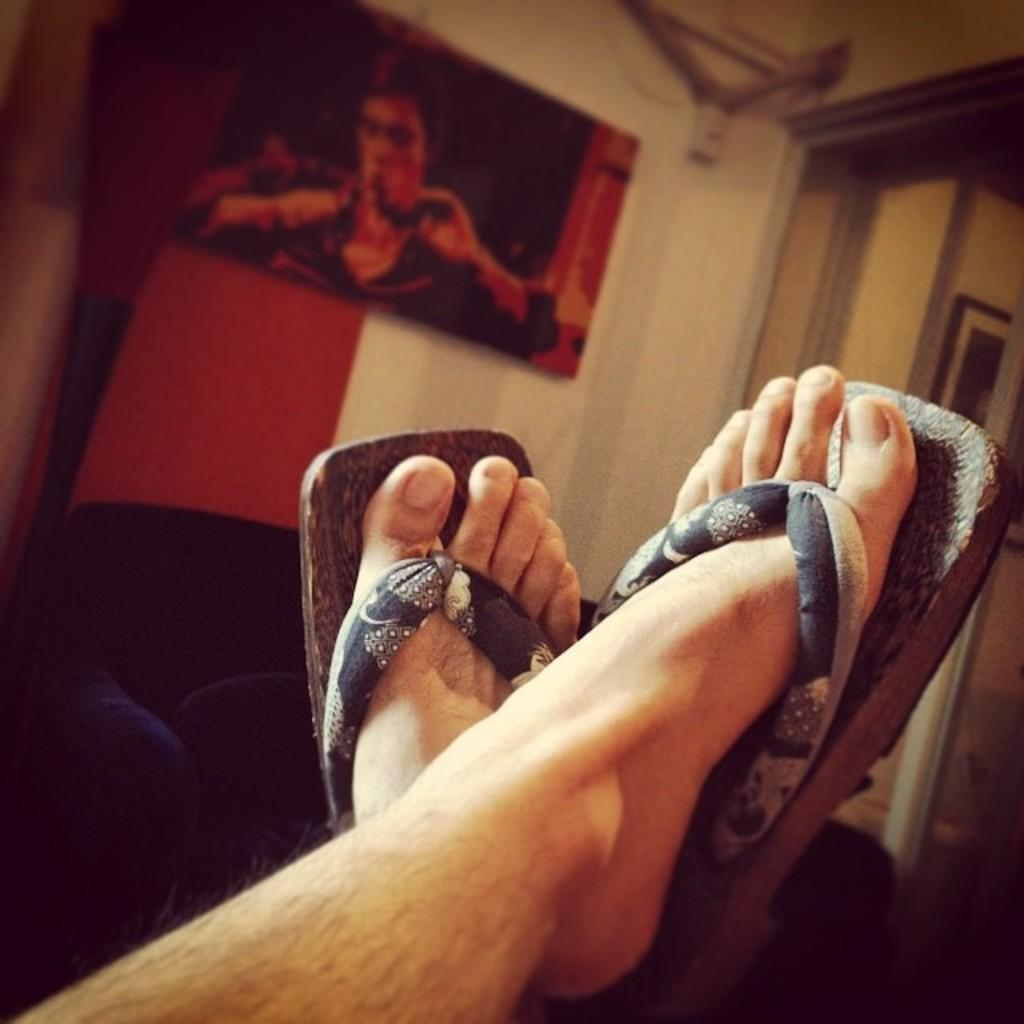What is present at the bottom of the image? There are legs with footwear in the image. What type of furniture or object is visible in the image? There is a cushion visible in the image. Where is the cushion located in relation to the wall? The cushion is near a wall. What is on the wall in the image? There is a poster on the wall. How many tickets are visible on the poster in the image? There are no tickets present on the poster in the image. What type of flock is flying near the legs with footwear in the image? There is no flock present in the image; it only features legs with footwear, a cushion, a wall, and a poster. 